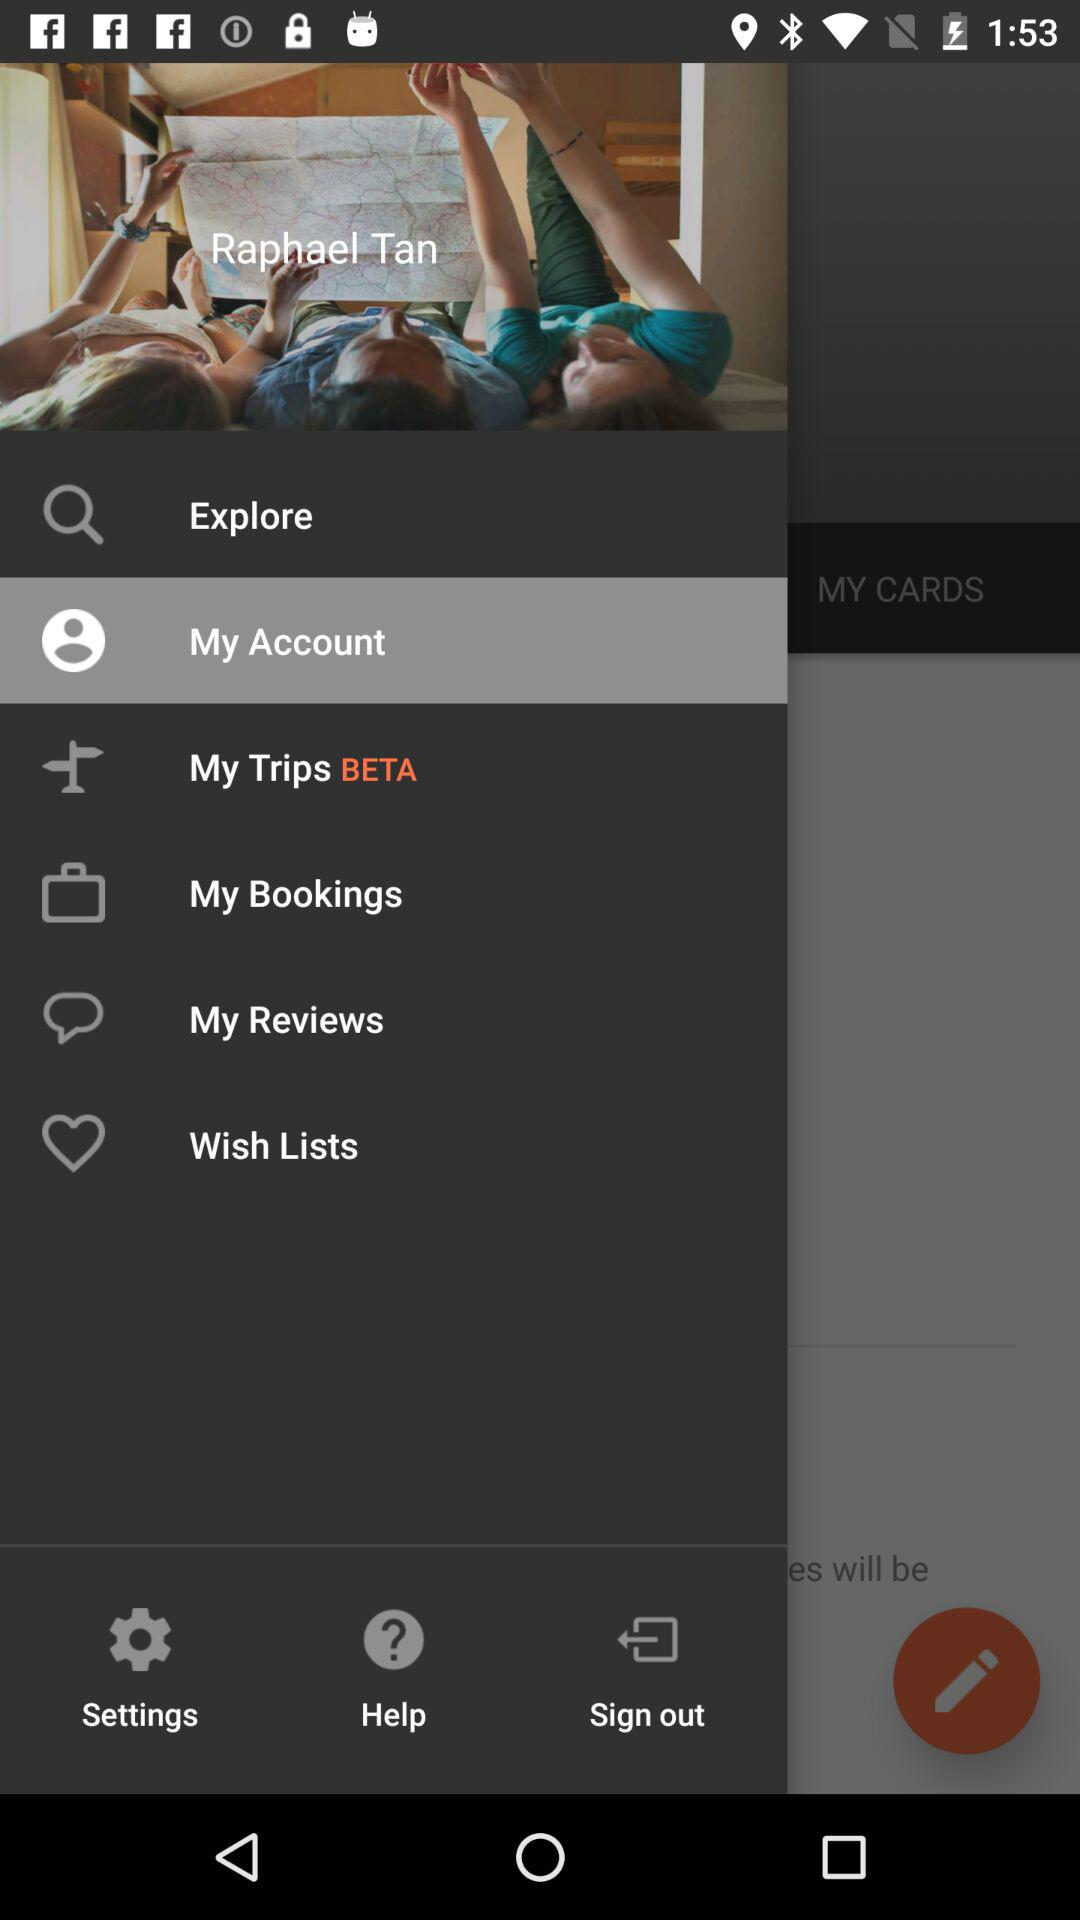Which option has been selected? The selected option is "My Account". 